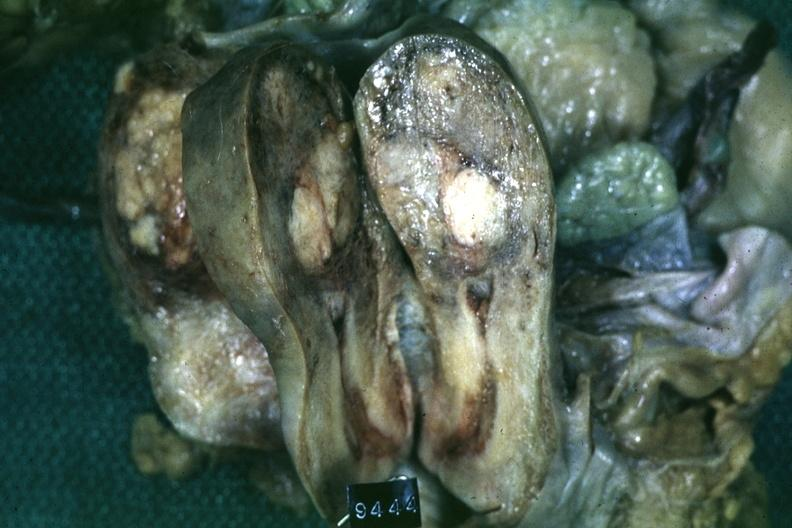does that show fixed tissue saggital section of organ with cross sectioned myoma?
Answer the question using a single word or phrase. No 